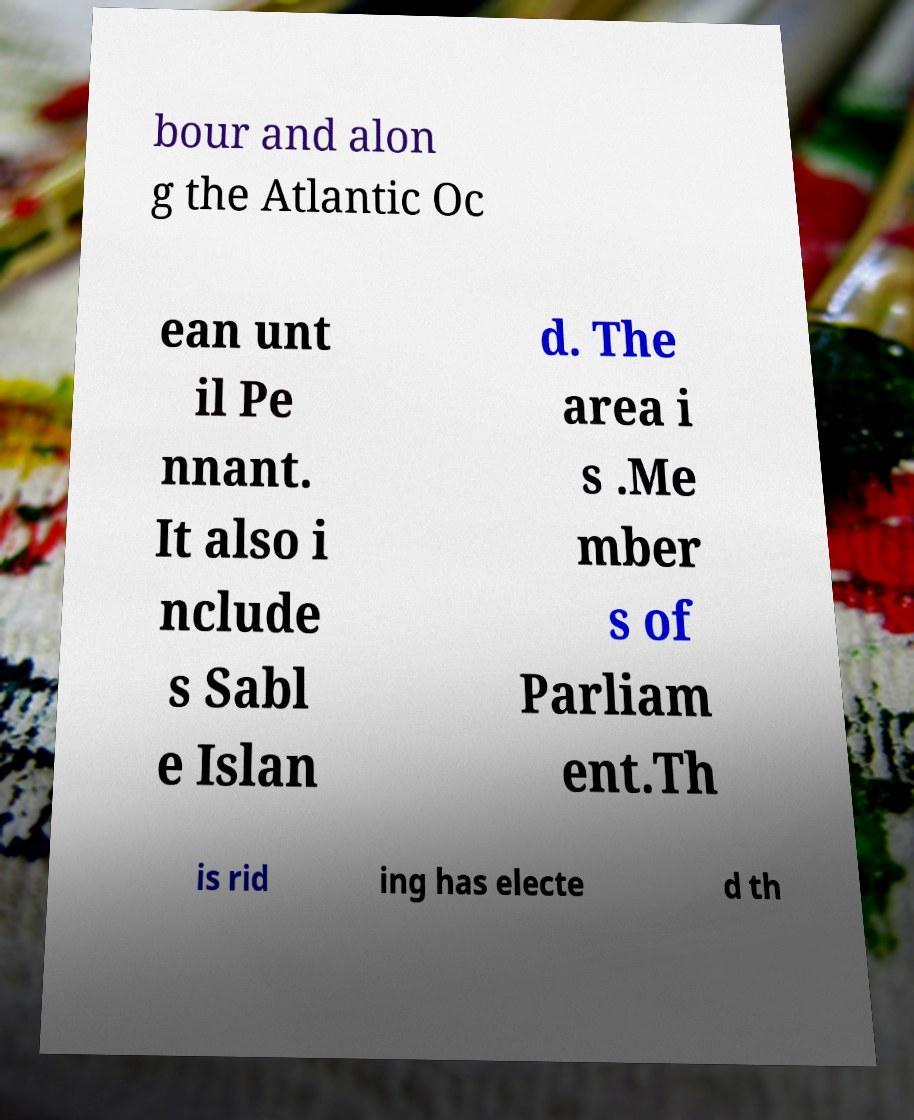What messages or text are displayed in this image? I need them in a readable, typed format. bour and alon g the Atlantic Oc ean unt il Pe nnant. It also i nclude s Sabl e Islan d. The area i s .Me mber s of Parliam ent.Th is rid ing has electe d th 